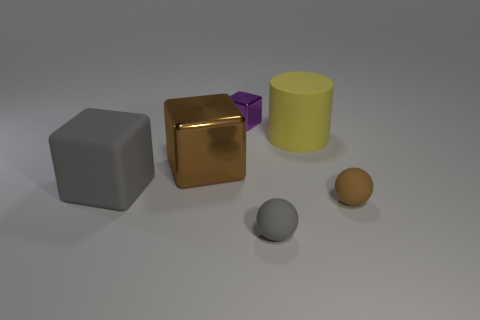Add 2 green cylinders. How many objects exist? 8 Subtract all matte cubes. How many cubes are left? 2 Subtract all brown cubes. How many cubes are left? 2 Subtract 0 brown cylinders. How many objects are left? 6 Subtract all spheres. How many objects are left? 4 Subtract 1 cylinders. How many cylinders are left? 0 Subtract all purple spheres. Subtract all blue cylinders. How many spheres are left? 2 Subtract all red blocks. How many brown spheres are left? 1 Subtract all gray spheres. Subtract all big brown objects. How many objects are left? 4 Add 1 big gray cubes. How many big gray cubes are left? 2 